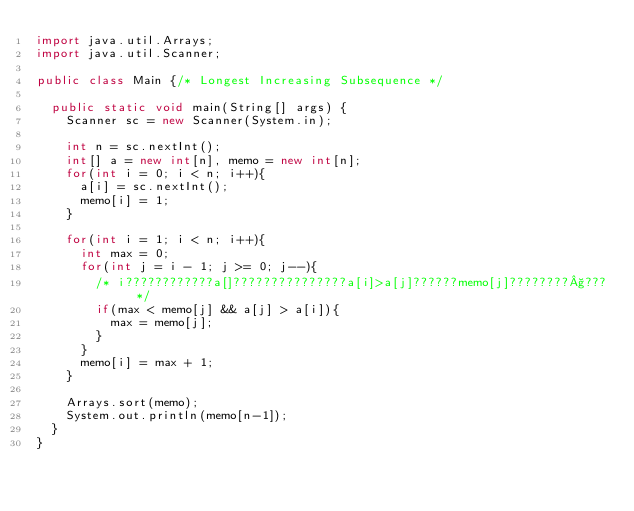Convert code to text. <code><loc_0><loc_0><loc_500><loc_500><_Java_>import java.util.Arrays;
import java.util.Scanner;

public class Main {/* Longest Increasing Subsequence */

	public static void main(String[] args) {
		Scanner sc = new Scanner(System.in);
		
		int n = sc.nextInt();
		int[] a = new int[n], memo = new int[n];
		for(int i = 0; i < n; i++){
			a[i] = sc.nextInt();
			memo[i] = 1;
		}

		for(int i = 1; i < n; i++){
			int max = 0;
			for(int j = i - 1; j >= 0; j--){
				/* i????????????a[]???????????????a[i]>a[j]??????memo[j]????????§??? */
				if(max < memo[j] && a[j] > a[i]){
					max = memo[j];
				}
			}
			memo[i] = max + 1;
		}
		
		Arrays.sort(memo);
		System.out.println(memo[n-1]);
	}
}</code> 